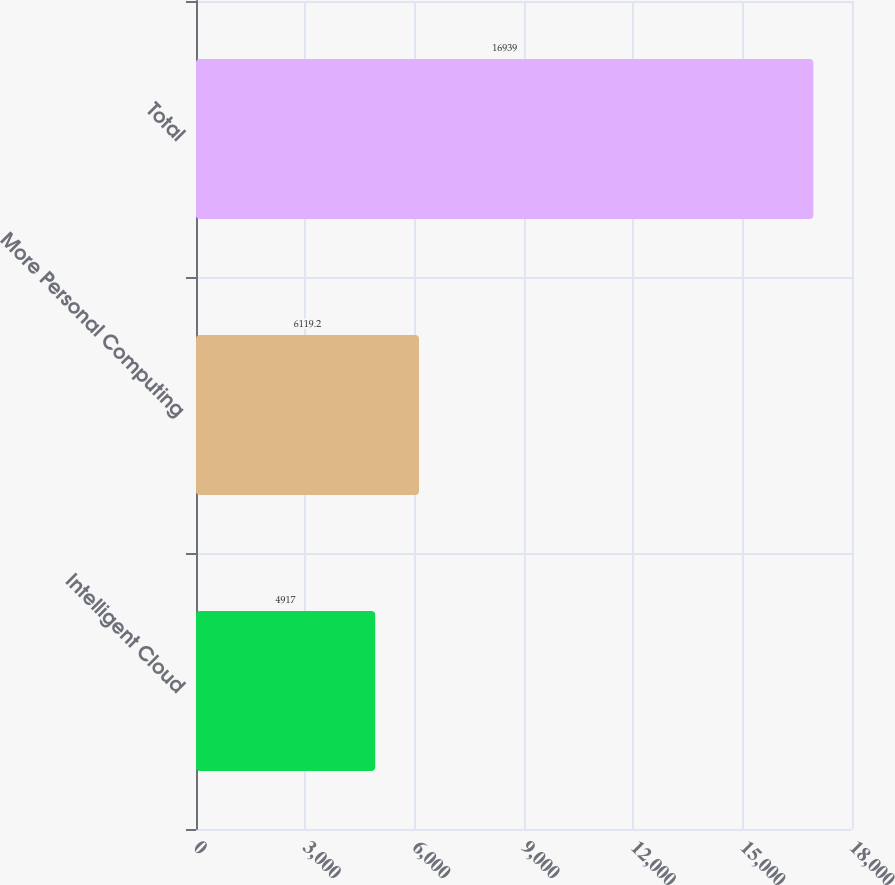Convert chart to OTSL. <chart><loc_0><loc_0><loc_500><loc_500><bar_chart><fcel>Intelligent Cloud<fcel>More Personal Computing<fcel>Total<nl><fcel>4917<fcel>6119.2<fcel>16939<nl></chart> 